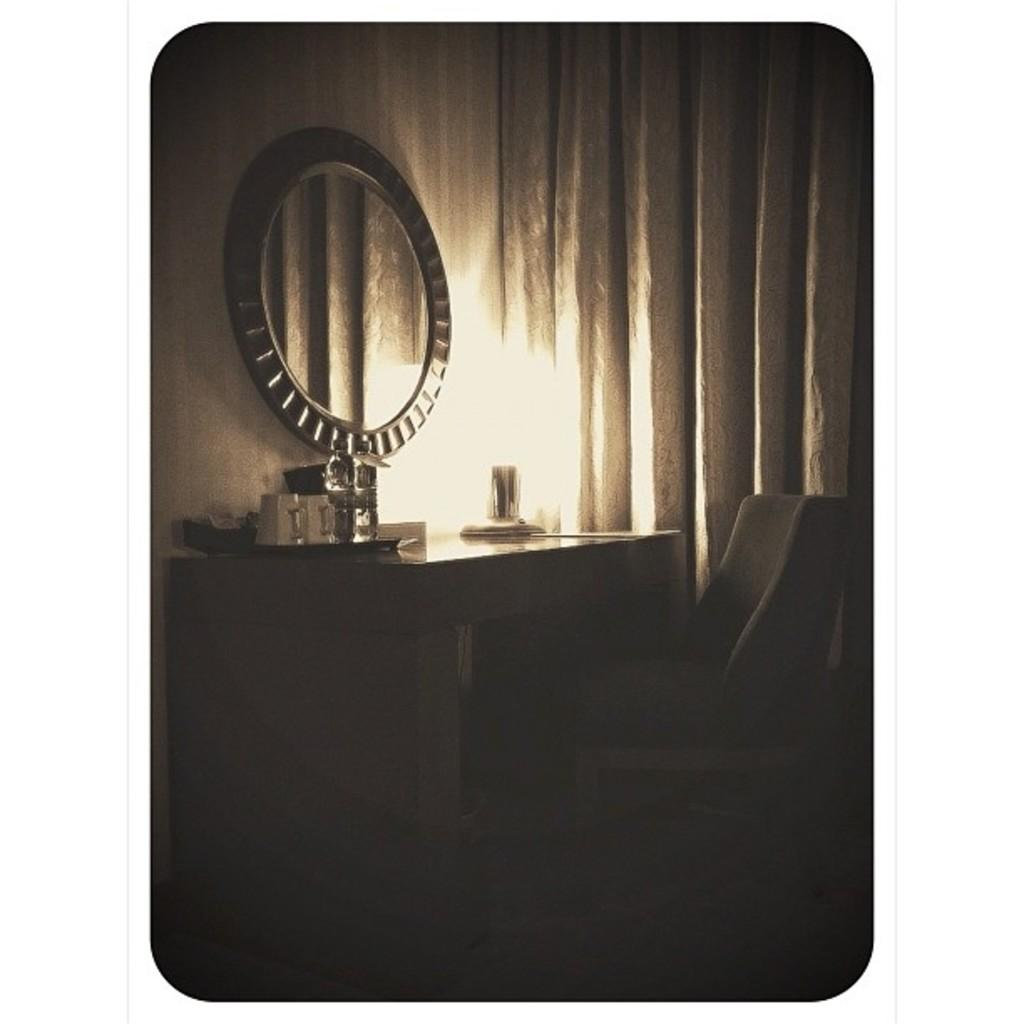What type of furniture is present in the image? There is a chair in the image. What type of window treatment is visible in the image? There are curtains in the image. What type of reflective surface is present in the image? There is a mirror in the image. What type of surface can objects be placed on in the image? There is a table in the image with objects on it. How would you describe the lighting in the image? The image is dark. What type of metal is used to create the chair in the image? There is no information about the type of metal used to create the chair in the image. What type of pleasure can be seen on the faces of the people in the image? There are no people present in the image, so we cannot determine if they are experiencing pleasure. 